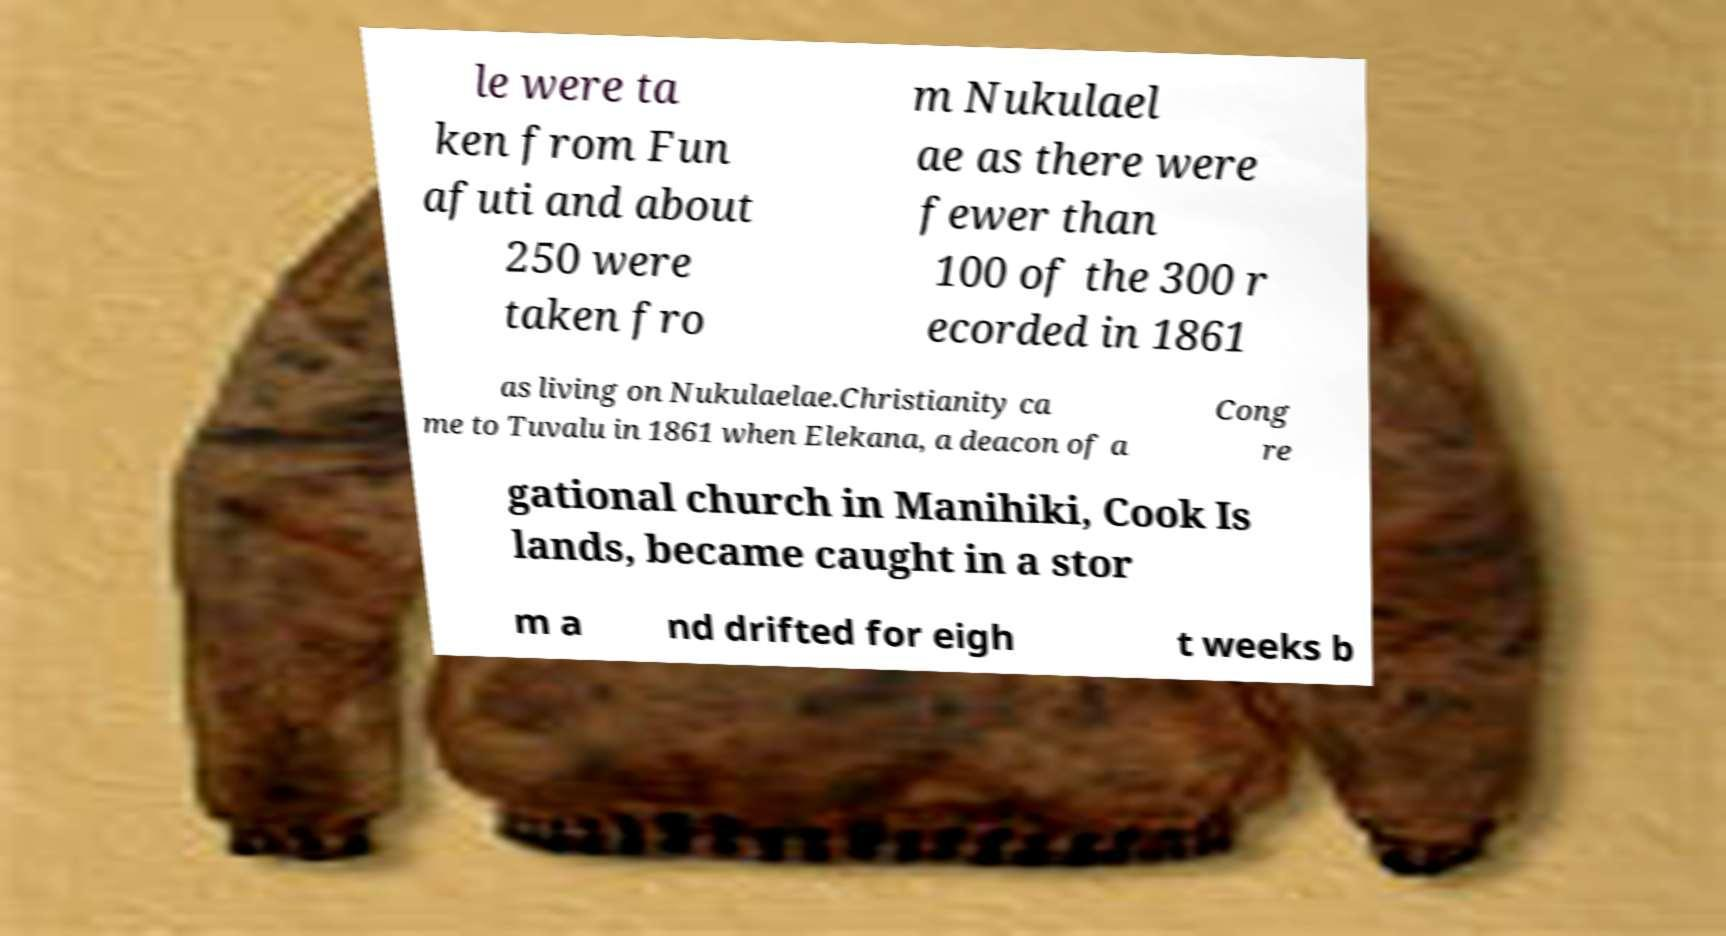For documentation purposes, I need the text within this image transcribed. Could you provide that? le were ta ken from Fun afuti and about 250 were taken fro m Nukulael ae as there were fewer than 100 of the 300 r ecorded in 1861 as living on Nukulaelae.Christianity ca me to Tuvalu in 1861 when Elekana, a deacon of a Cong re gational church in Manihiki, Cook Is lands, became caught in a stor m a nd drifted for eigh t weeks b 